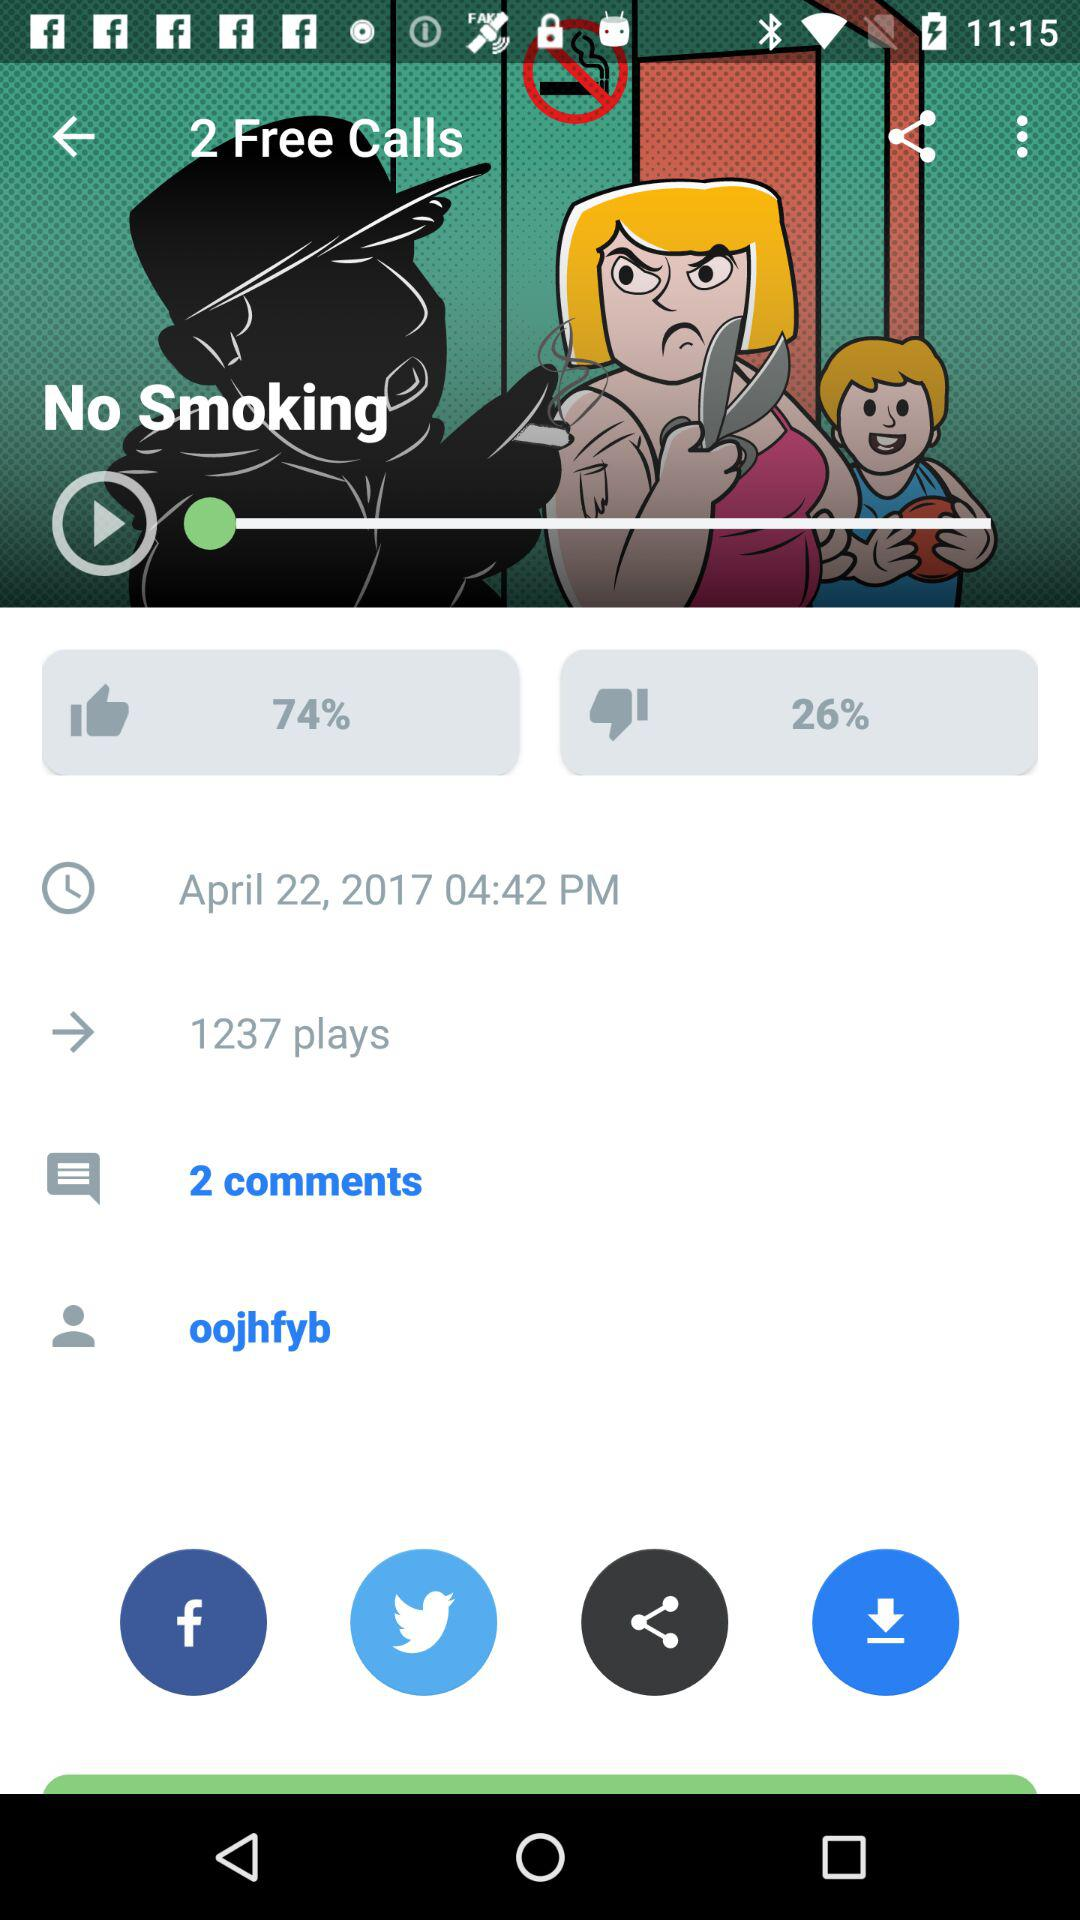How many free calls are shown?
When the provided information is insufficient, respond with <no answer>. <no answer> 